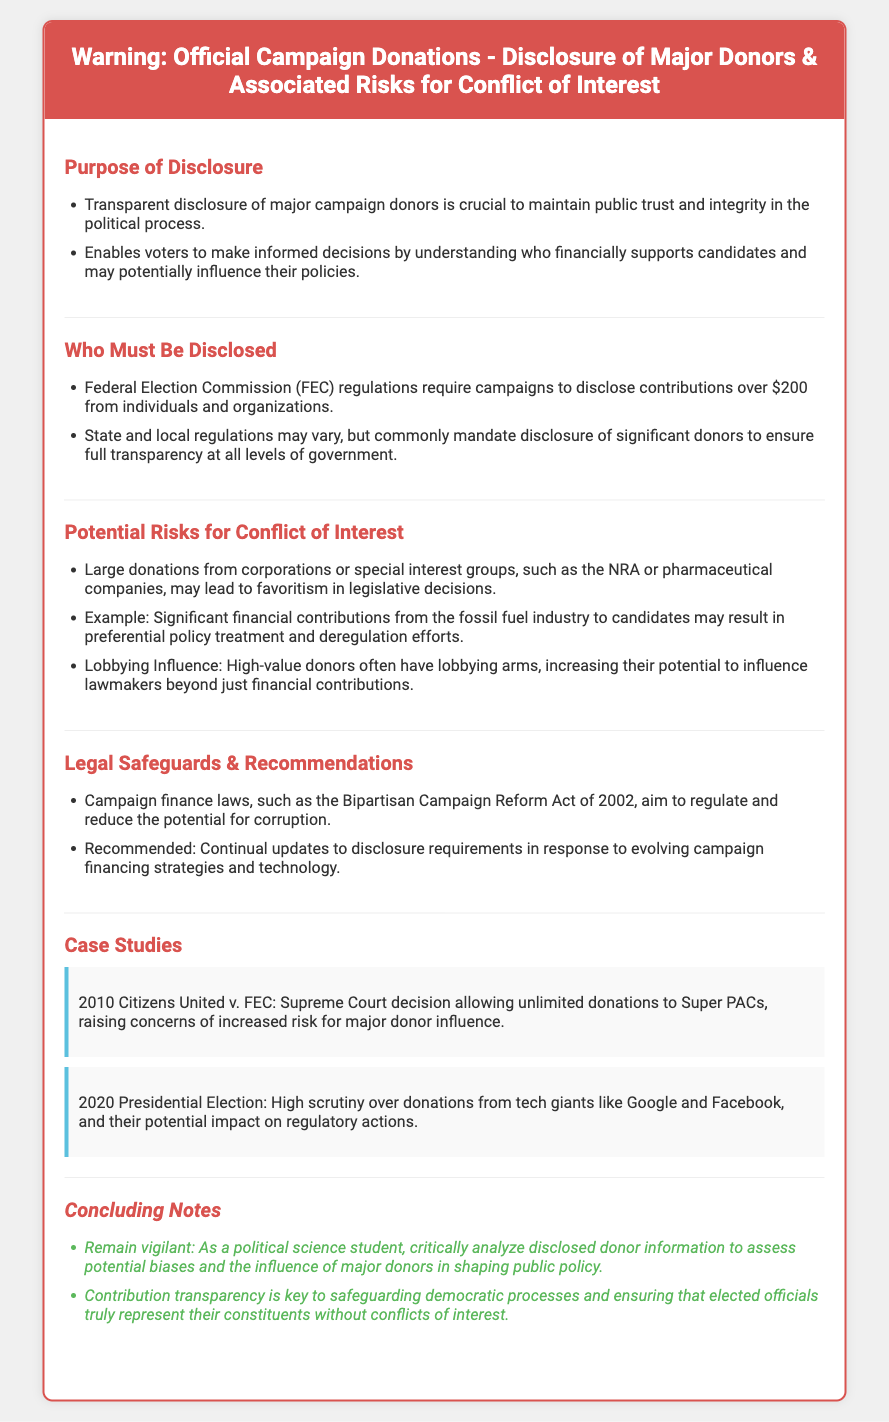What is the purpose of donor disclosure? The purpose includes maintaining public trust and enabling informed voter decisions regarding campaign donors.
Answer: Transparent disclosure of major campaign donors Who must be disclosed according to FEC regulations? FEC regulations require campaigns to disclose contributions over $200 from individuals and organizations.
Answer: Contributions over $200 What is a potential risk associated with large donations? Large donations can lead to favoritism in legislative decisions.
Answer: Favoritism What legal safeguard is mentioned in the document? The document mentions the Bipartisan Campaign Reform Act of 2002 as a regulation aimed to reduce corruption.
Answer: Bipartisan Campaign Reform Act of 2002 What case study is provided regarding donor influence? Citizens United v. FEC is cited as a key case that raised concerns about donor influence on elections.
Answer: Citizens United v. FEC What specific example of donor influence is highlighted? Significant donations from the fossil fuel industry could lead to preferential policy treatment.
Answer: Fossil fuel industry What should political science students do with disclosed donor information? Students should critically analyze disclosed donor information to assess potential biases.
Answer: Critically analyze disclosed donor information 